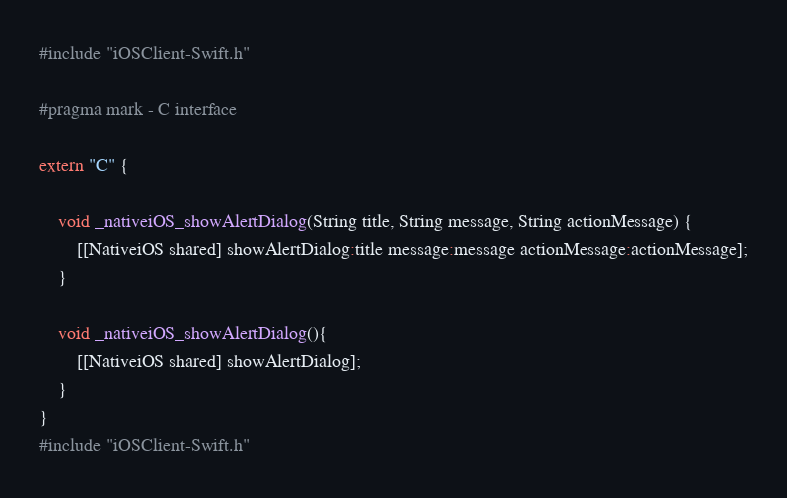<code> <loc_0><loc_0><loc_500><loc_500><_ObjectiveC_>#include "iOSClient-Swift.h"

#pragma mark - C interface

extern "C" {
    
    void _nativeiOS_showAlertDialog(String title, String message, String actionMessage) {
        [[NativeiOS shared] showAlertDialog:title message:message actionMessage:actionMessage];
    }
    
    void _nativeiOS_showAlertDialog(){
        [[NativeiOS shared] showAlertDialog];
    }
}
#include "iOSClient-Swift.h"
</code> 